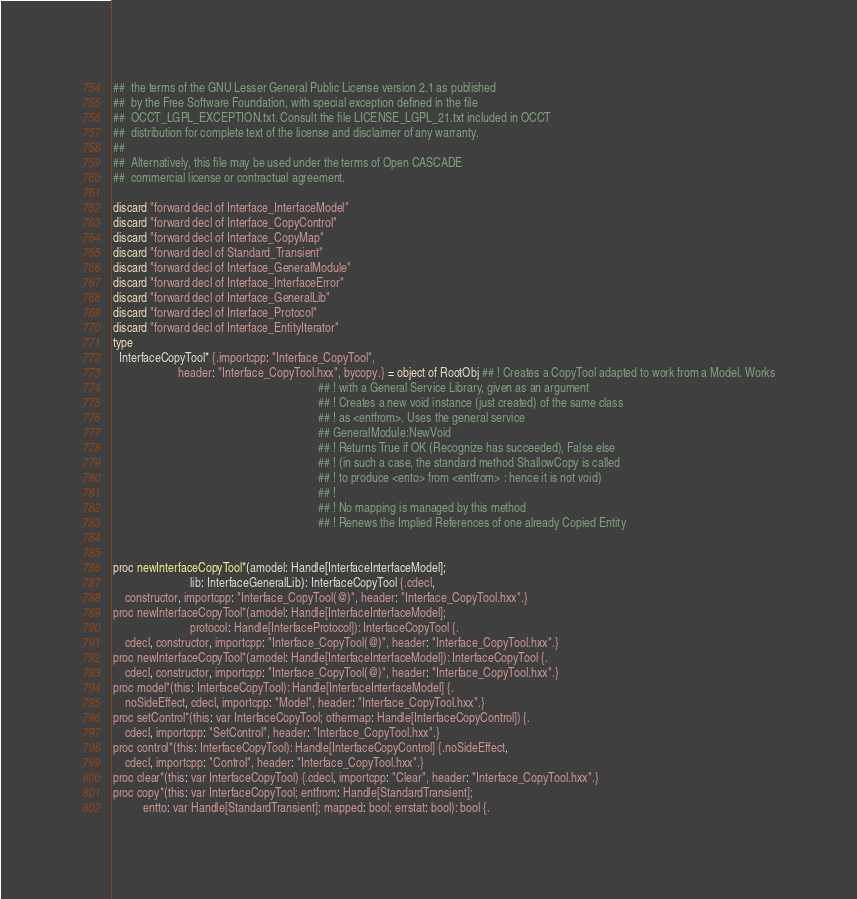<code> <loc_0><loc_0><loc_500><loc_500><_Nim_>##  the terms of the GNU Lesser General Public License version 2.1 as published
##  by the Free Software Foundation, with special exception defined in the file
##  OCCT_LGPL_EXCEPTION.txt. Consult the file LICENSE_LGPL_21.txt included in OCCT
##  distribution for complete text of the license and disclaimer of any warranty.
##
##  Alternatively, this file may be used under the terms of Open CASCADE
##  commercial license or contractual agreement.

discard "forward decl of Interface_InterfaceModel"
discard "forward decl of Interface_CopyControl"
discard "forward decl of Interface_CopyMap"
discard "forward decl of Standard_Transient"
discard "forward decl of Interface_GeneralModule"
discard "forward decl of Interface_InterfaceError"
discard "forward decl of Interface_GeneralLib"
discard "forward decl of Interface_Protocol"
discard "forward decl of Interface_EntityIterator"
type
  InterfaceCopyTool* {.importcpp: "Interface_CopyTool",
                      header: "Interface_CopyTool.hxx", bycopy.} = object of RootObj ## ! Creates a CopyTool adapted to work from a Model. Works
                                                                     ## ! with a General Service Library, given as an argument
                                                                     ## ! Creates a new void instance (just created) of the same class
                                                                     ## ! as <entfrom>. Uses the general service
                                                                     ## GeneralModule:NewVoid
                                                                     ## ! Returns True if OK (Recognize has succeeded), False else
                                                                     ## ! (in such a case, the standard method ShallowCopy is called
                                                                     ## ! to produce <ento> from <entfrom> : hence it is not void)
                                                                     ## !
                                                                     ## ! No mapping is managed by this method
                                                                     ## ! Renews the Implied References of one already Copied Entity


proc newInterfaceCopyTool*(amodel: Handle[InterfaceInterfaceModel];
                          lib: InterfaceGeneralLib): InterfaceCopyTool {.cdecl,
    constructor, importcpp: "Interface_CopyTool(@)", header: "Interface_CopyTool.hxx".}
proc newInterfaceCopyTool*(amodel: Handle[InterfaceInterfaceModel];
                          protocol: Handle[InterfaceProtocol]): InterfaceCopyTool {.
    cdecl, constructor, importcpp: "Interface_CopyTool(@)", header: "Interface_CopyTool.hxx".}
proc newInterfaceCopyTool*(amodel: Handle[InterfaceInterfaceModel]): InterfaceCopyTool {.
    cdecl, constructor, importcpp: "Interface_CopyTool(@)", header: "Interface_CopyTool.hxx".}
proc model*(this: InterfaceCopyTool): Handle[InterfaceInterfaceModel] {.
    noSideEffect, cdecl, importcpp: "Model", header: "Interface_CopyTool.hxx".}
proc setControl*(this: var InterfaceCopyTool; othermap: Handle[InterfaceCopyControl]) {.
    cdecl, importcpp: "SetControl", header: "Interface_CopyTool.hxx".}
proc control*(this: InterfaceCopyTool): Handle[InterfaceCopyControl] {.noSideEffect,
    cdecl, importcpp: "Control", header: "Interface_CopyTool.hxx".}
proc clear*(this: var InterfaceCopyTool) {.cdecl, importcpp: "Clear", header: "Interface_CopyTool.hxx".}
proc copy*(this: var InterfaceCopyTool; entfrom: Handle[StandardTransient];
          entto: var Handle[StandardTransient]; mapped: bool; errstat: bool): bool {.</code> 